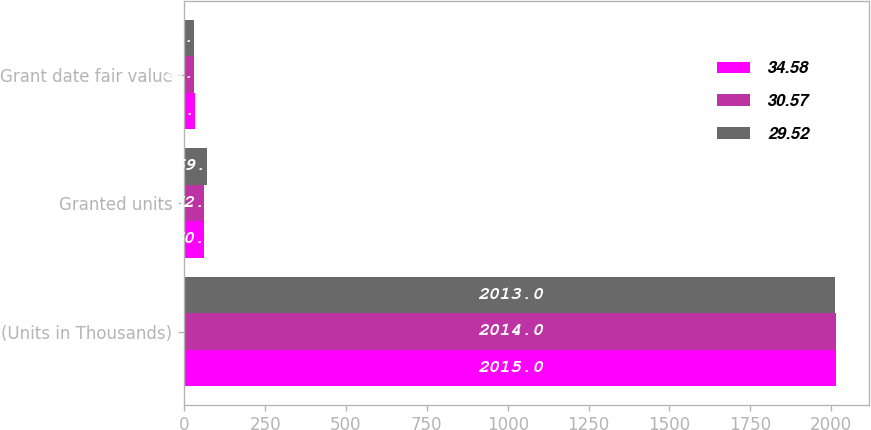Convert chart to OTSL. <chart><loc_0><loc_0><loc_500><loc_500><stacked_bar_chart><ecel><fcel>(Units in Thousands)<fcel>Granted units<fcel>Grant date fair value<nl><fcel>34.58<fcel>2015<fcel>60<fcel>34.58<nl><fcel>30.57<fcel>2014<fcel>62<fcel>30.57<nl><fcel>29.52<fcel>2013<fcel>69<fcel>29.52<nl></chart> 